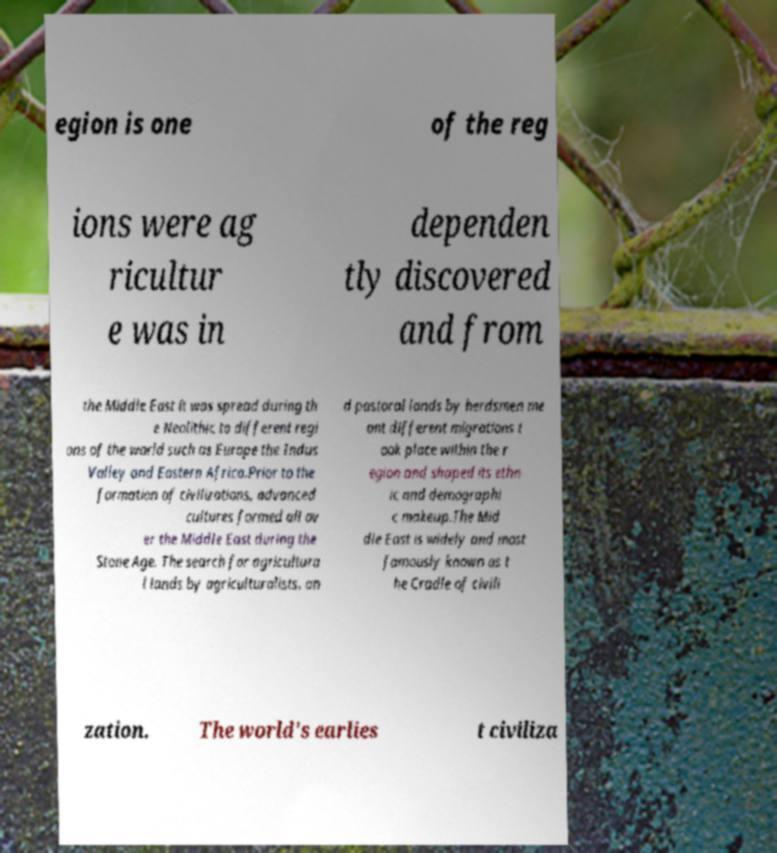Could you extract and type out the text from this image? egion is one of the reg ions were ag ricultur e was in dependen tly discovered and from the Middle East it was spread during th e Neolithic to different regi ons of the world such as Europe the Indus Valley and Eastern Africa.Prior to the formation of civilizations, advanced cultures formed all ov er the Middle East during the Stone Age. The search for agricultura l lands by agriculturalists, an d pastoral lands by herdsmen me ant different migrations t ook place within the r egion and shaped its ethn ic and demographi c makeup.The Mid dle East is widely and most famously known as t he Cradle of civili zation. The world's earlies t civiliza 